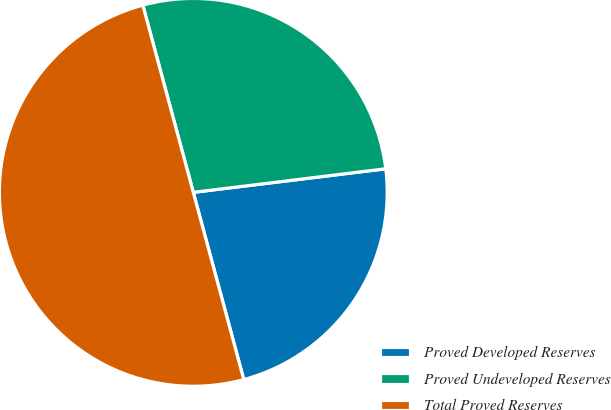<chart> <loc_0><loc_0><loc_500><loc_500><pie_chart><fcel>Proved Developed Reserves<fcel>Proved Undeveloped Reserves<fcel>Total Proved Reserves<nl><fcel>22.75%<fcel>27.25%<fcel>50.0%<nl></chart> 